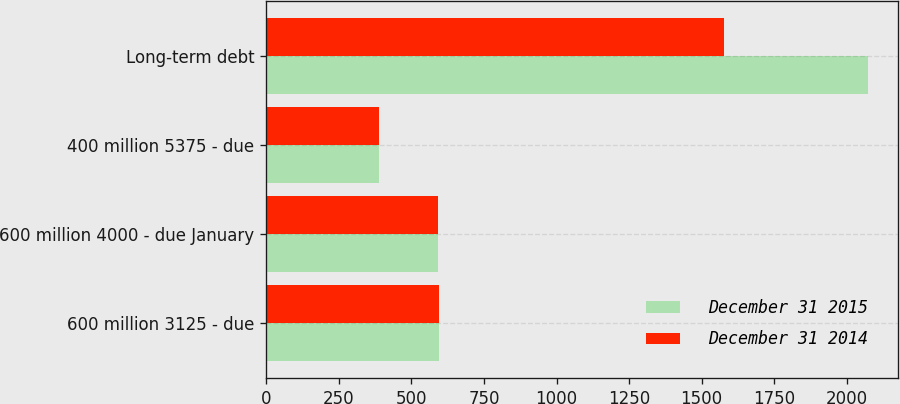<chart> <loc_0><loc_0><loc_500><loc_500><stacked_bar_chart><ecel><fcel>600 million 3125 - due<fcel>600 million 4000 - due January<fcel>400 million 5375 - due<fcel>Long-term debt<nl><fcel>December 31 2015<fcel>596.1<fcel>592.7<fcel>389.8<fcel>2072.8<nl><fcel>December 31 2014<fcel>595.4<fcel>591.9<fcel>389.5<fcel>1576.8<nl></chart> 